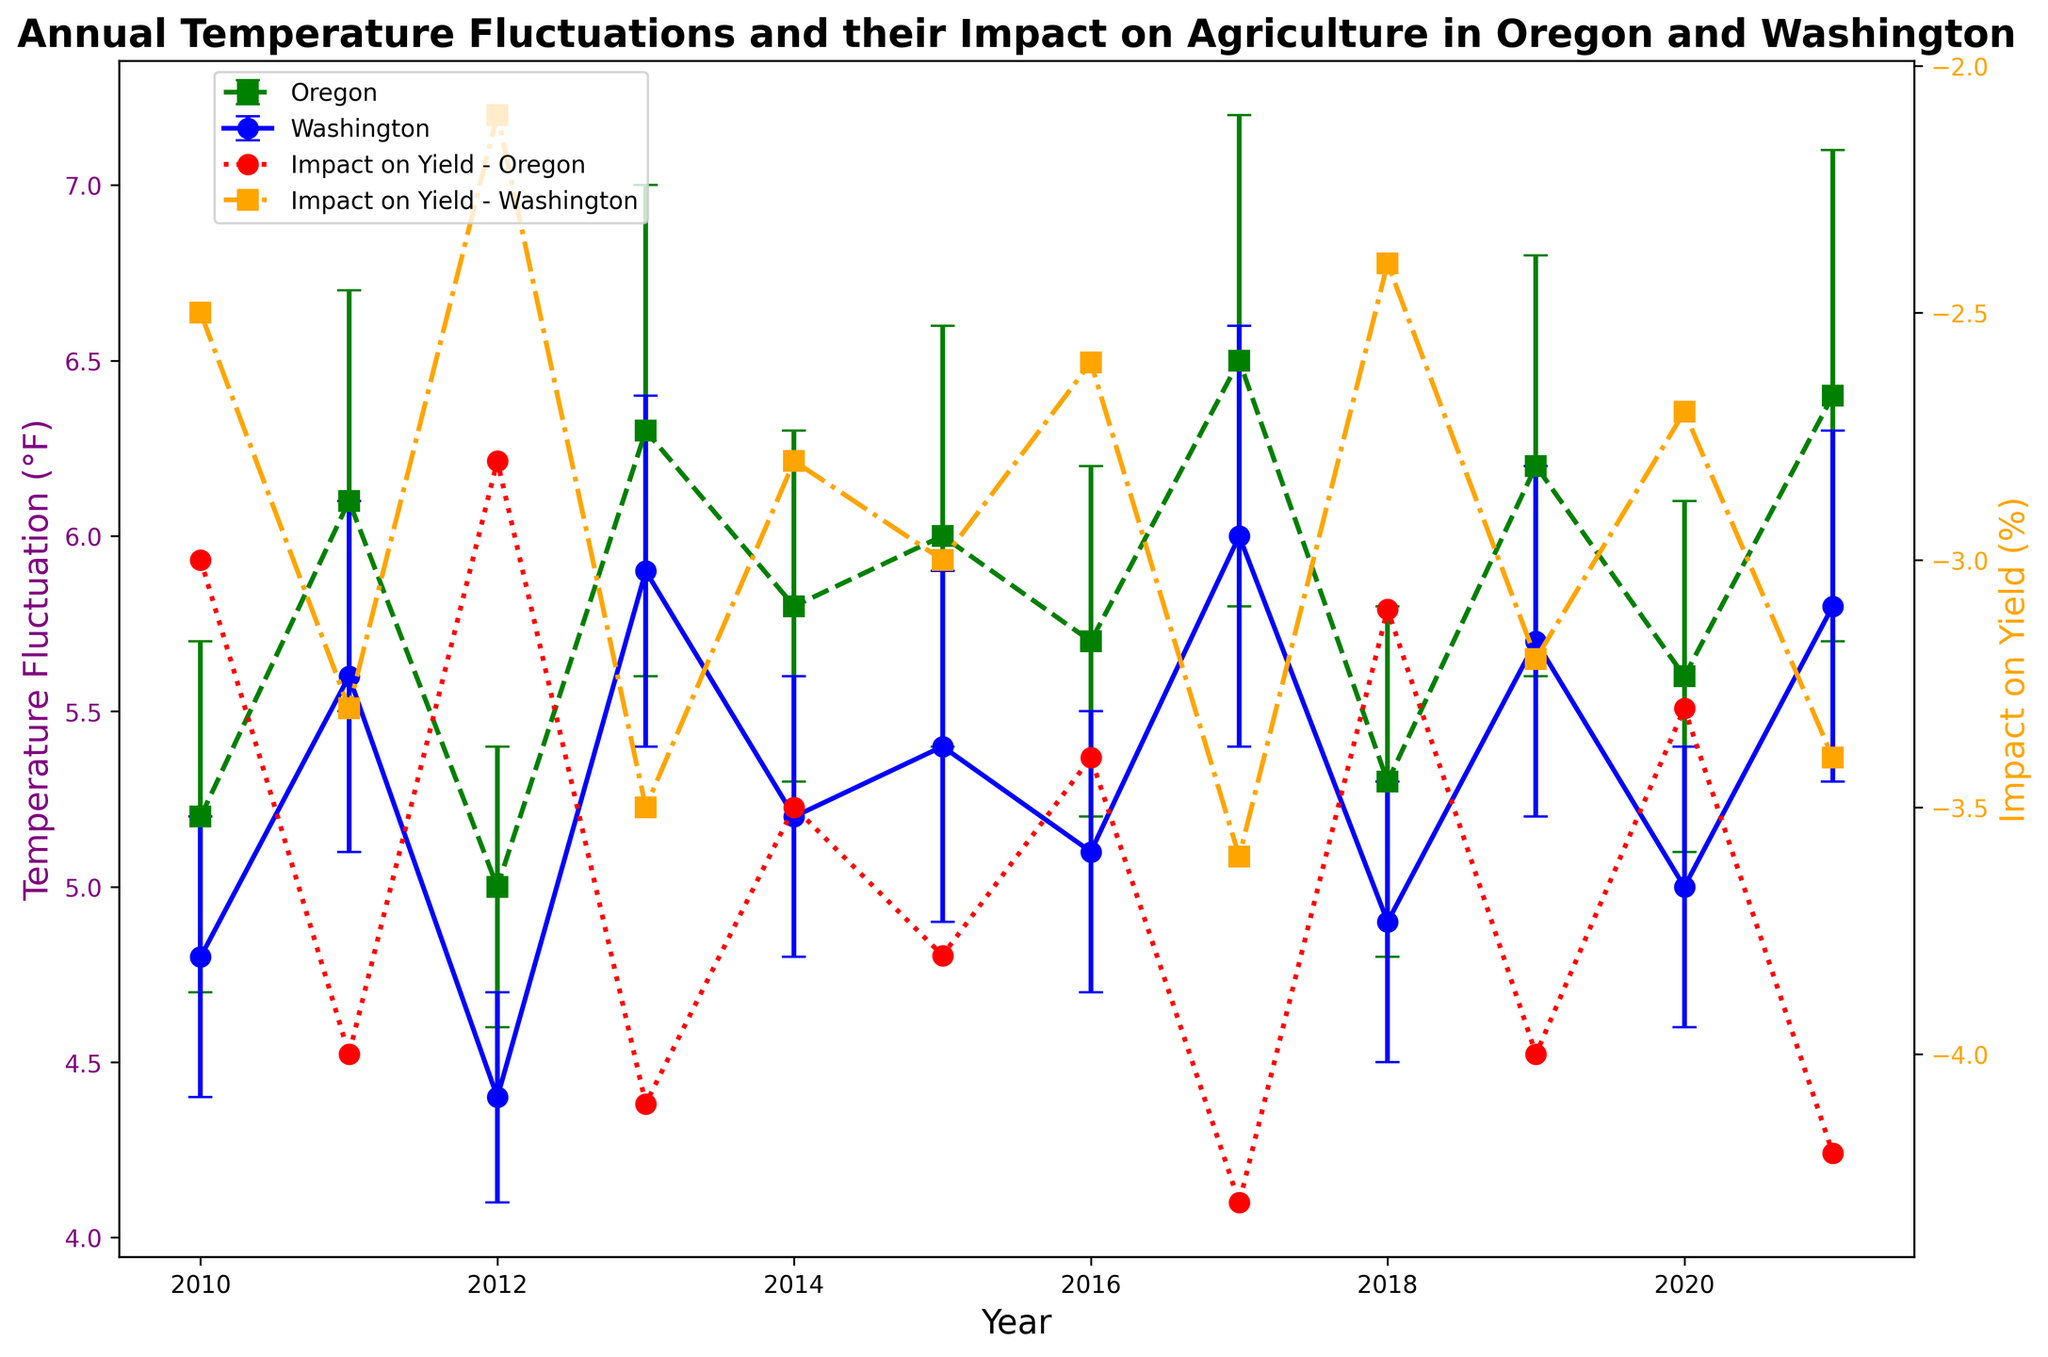What is the average annual temperature fluctuation in Oregon over the given years? Add all the temperature fluctuations for Oregon from each year and divide by the number of years. That is (5.2 + 6.1 + 5.0 + 6.3 + 5.8 + 6.0 + 5.7 + 6.5 + 5.3 + 6.2 + 5.6 + 6.4) / 12 = 69.1 / 12 ≈ 5.76°F
Answer: 5.76°F Which state had the highest temperature fluctuation in 2017? Compare the temperature fluctuations for Oregon and Washington in 2017. Oregon had a fluctuation of 6.5°F, while Washington had 6.0°F. Therefore, Oregon had the higher fluctuation.
Answer: Oregon In which year did Washington experience the lowest temperature fluctuation and what was the value? Examine the temperature fluctuations for Washington across all years and identify the smallest value. In 2012, Washington had a temperature fluctuation of 4.4°F, which is the lowest among all years.
Answer: 2012, 4.4°F During which year did both states have the closest temperature fluctuation values, and what were those values? Look for years with minimal difference in temperature fluctuation between Oregon and Washington. In 2010, Oregon had a fluctuation of 5.2°F and Washington had 4.8°F, with a difference of 0.4°F (the smallest difference among all years).
Answer: 2010, 5.2°F and 4.8°F What is the general trend in the impact on yield for Oregon as temperature fluctuations increase? Look at the visual trends for Oregon's yield impact line (red) against the temperature fluctuations (green). Generally, as temperature fluctuations increase, the impact on yield becomes more negative, indicating higher temperature fluctuations lead to more negative impacts on yield.
Answer: More negative impact on yield How do the error margins compare between Oregon and Washington for most years? By examining the error bars' lengths for both states, we notice that Oregon generally has slightly larger error margins than Washington. For instance, in 2017, Oregon's error margin is 0.7°F, while Washington's is 0.6°F.
Answer: Oregon generally has larger error margins Which year had the highest negative impact on yield for Washington? Check the data for the most negative values in Washington's yield impact line (orange). The highest negative impact on yield for Washington is in 2017 at -3.6%.
Answer: 2017 Is there any year where the impact on yield for both states had a positive value? Scan the entire Impact on Yield lines (red and orange) on the secondary y-axis. There are no instances of positive yield impacts; all values are negative throughout the years.
Answer: No On average, which state had a larger impact on yield? Compute the average impact on yield for both states. For Oregon, average is (-3 - 4 - 2.8 - 4.1 - 3.5 - 3.8 - 3.4 - 4.3 - 3.1 - 4 - 3.3 - 4.2) / 12 ≈ -3.65%. For Washington, average is (-2.5 - 3.3 - 2.1 - 3.5 - 2.8 - 3.0 - 2.6 - 3.6 - 2.4 - 3.2 - 2.7 - 3.4) / 12 ≈ -2.96%. Oregon had a larger negative impact on yield on average.
Answer: Oregon What is the difference in temperature fluctuations between Washington and Oregon in 2019? Check the temperature fluctuation values for both states in 2019. Oregon has 6.2°F and Washington has 5.7°F. The difference is 6.2 - 5.7 = 0.5°F.
Answer: 0.5°F 